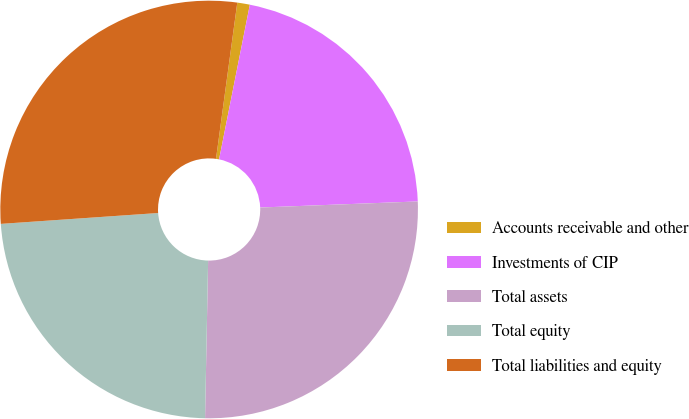<chart> <loc_0><loc_0><loc_500><loc_500><pie_chart><fcel>Accounts receivable and other<fcel>Investments of CIP<fcel>Total assets<fcel>Total equity<fcel>Total liabilities and equity<nl><fcel>0.97%<fcel>21.26%<fcel>25.92%<fcel>23.59%<fcel>28.25%<nl></chart> 